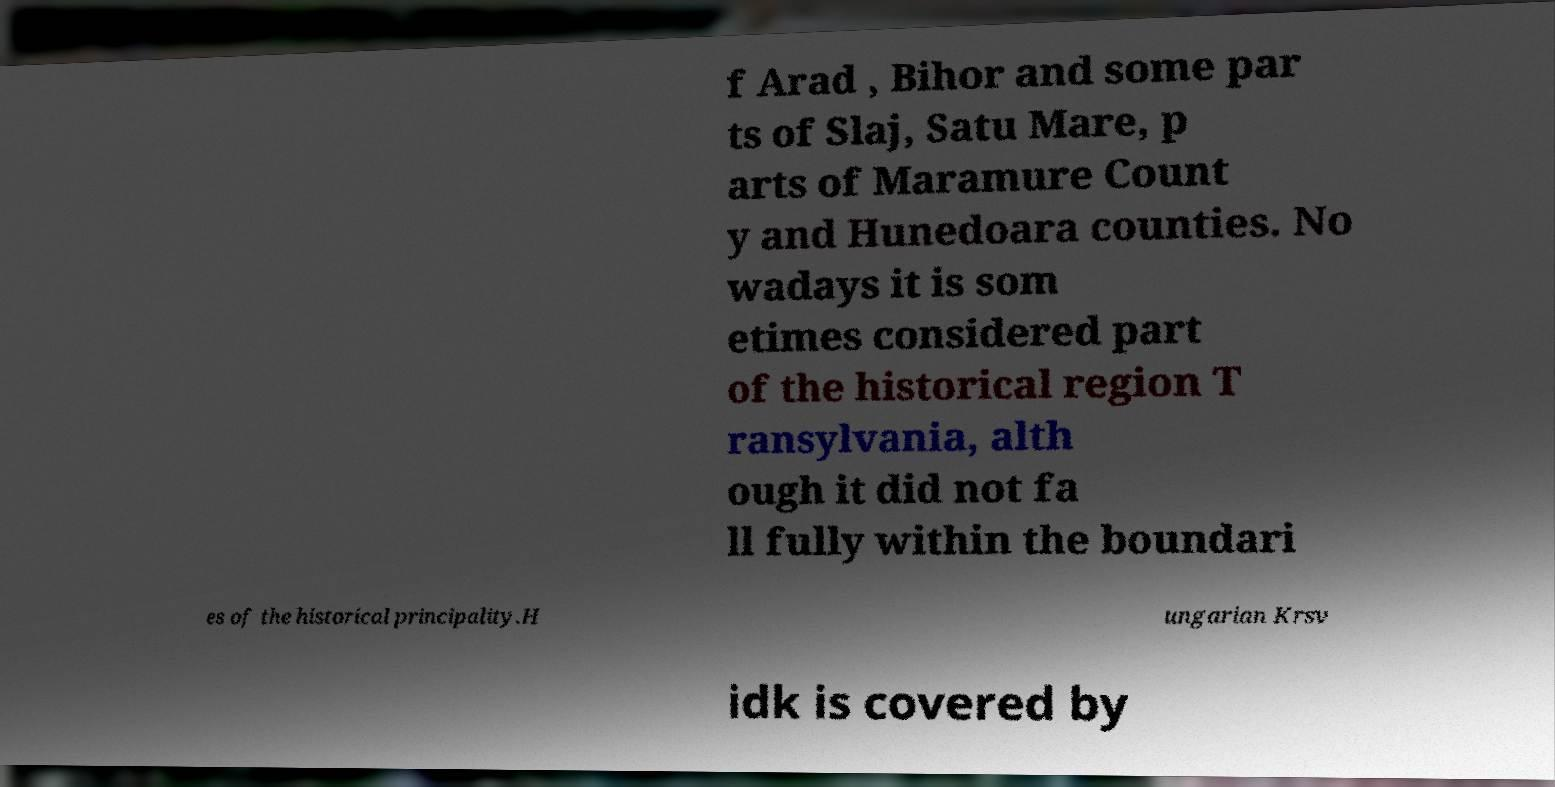I need the written content from this picture converted into text. Can you do that? f Arad , Bihor and some par ts of Slaj, Satu Mare, p arts of Maramure Count y and Hunedoara counties. No wadays it is som etimes considered part of the historical region T ransylvania, alth ough it did not fa ll fully within the boundari es of the historical principality.H ungarian Krsv idk is covered by 